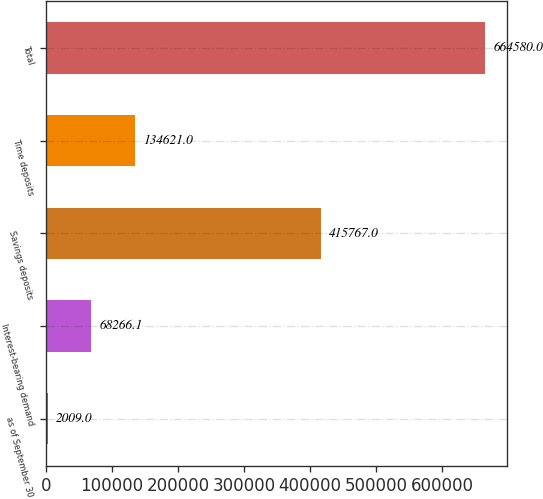Convert chart to OTSL. <chart><loc_0><loc_0><loc_500><loc_500><bar_chart><fcel>as of September 30<fcel>Interest-bearing demand<fcel>Savings deposits<fcel>Time deposits<fcel>Total<nl><fcel>2009<fcel>68266.1<fcel>415767<fcel>134621<fcel>664580<nl></chart> 